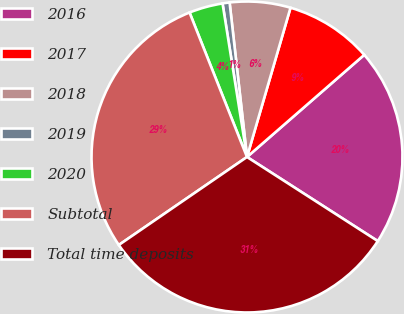<chart> <loc_0><loc_0><loc_500><loc_500><pie_chart><fcel>2016<fcel>2017<fcel>2018<fcel>2019<fcel>2020<fcel>Subtotal<fcel>Total time deposits<nl><fcel>20.5%<fcel>9.08%<fcel>6.3%<fcel>0.73%<fcel>3.51%<fcel>28.55%<fcel>31.33%<nl></chart> 